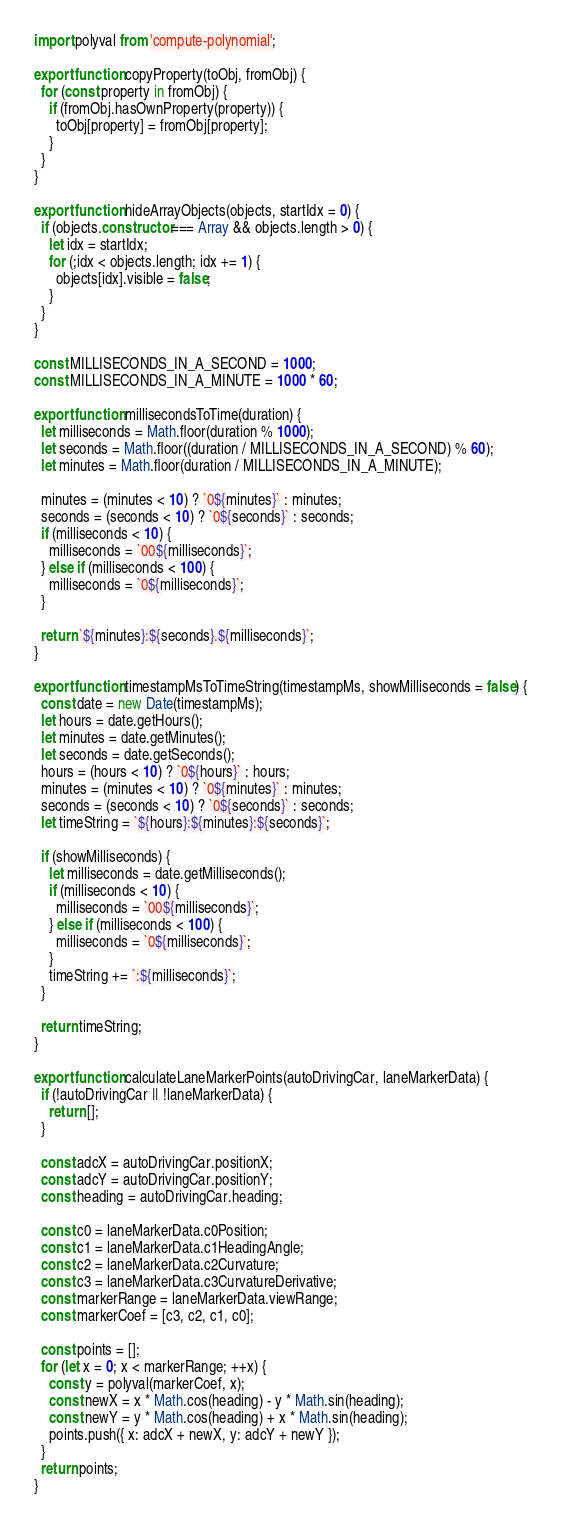Convert code to text. <code><loc_0><loc_0><loc_500><loc_500><_JavaScript_>import polyval from 'compute-polynomial';

export function copyProperty(toObj, fromObj) {
  for (const property in fromObj) {
    if (fromObj.hasOwnProperty(property)) {
      toObj[property] = fromObj[property];
    }
  }
}

export function hideArrayObjects(objects, startIdx = 0) {
  if (objects.constructor === Array && objects.length > 0) {
    let idx = startIdx;
    for (;idx < objects.length; idx += 1) {
      objects[idx].visible = false;
    }
  }
}

const MILLISECONDS_IN_A_SECOND = 1000;
const MILLISECONDS_IN_A_MINUTE = 1000 * 60;

export function millisecondsToTime(duration) {
  let milliseconds = Math.floor(duration % 1000);
  let seconds = Math.floor((duration / MILLISECONDS_IN_A_SECOND) % 60);
  let minutes = Math.floor(duration / MILLISECONDS_IN_A_MINUTE);

  minutes = (minutes < 10) ? `0${minutes}` : minutes;
  seconds = (seconds < 10) ? `0${seconds}` : seconds;
  if (milliseconds < 10) {
    milliseconds = `00${milliseconds}`;
  } else if (milliseconds < 100) {
    milliseconds = `0${milliseconds}`;
  }

  return `${minutes}:${seconds}.${milliseconds}`;
}

export function timestampMsToTimeString(timestampMs, showMilliseconds = false) {
  const date = new Date(timestampMs);
  let hours = date.getHours();
  let minutes = date.getMinutes();
  let seconds = date.getSeconds();
  hours = (hours < 10) ? `0${hours}` : hours;
  minutes = (minutes < 10) ? `0${minutes}` : minutes;
  seconds = (seconds < 10) ? `0${seconds}` : seconds;
  let timeString = `${hours}:${minutes}:${seconds}`;

  if (showMilliseconds) {
    let milliseconds = date.getMilliseconds();
    if (milliseconds < 10) {
      milliseconds = `00${milliseconds}`;
    } else if (milliseconds < 100) {
      milliseconds = `0${milliseconds}`;
    }
    timeString += `:${milliseconds}`;
  }

  return timeString;
}

export function calculateLaneMarkerPoints(autoDrivingCar, laneMarkerData) {
  if (!autoDrivingCar || !laneMarkerData) {
    return [];
  }

  const adcX = autoDrivingCar.positionX;
  const adcY = autoDrivingCar.positionY;
  const heading = autoDrivingCar.heading;

  const c0 = laneMarkerData.c0Position;
  const c1 = laneMarkerData.c1HeadingAngle;
  const c2 = laneMarkerData.c2Curvature;
  const c3 = laneMarkerData.c3CurvatureDerivative;
  const markerRange = laneMarkerData.viewRange;
  const markerCoef = [c3, c2, c1, c0];

  const points = [];
  for (let x = 0; x < markerRange; ++x) {
    const y = polyval(markerCoef, x);
    const newX = x * Math.cos(heading) - y * Math.sin(heading);
    const newY = y * Math.cos(heading) + x * Math.sin(heading);
    points.push({ x: adcX + newX, y: adcY + newY });
  }
  return points;
}
</code> 